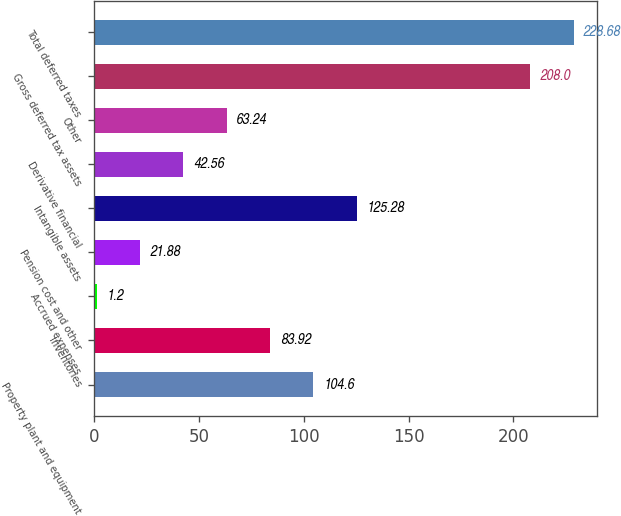<chart> <loc_0><loc_0><loc_500><loc_500><bar_chart><fcel>Property plant and equipment<fcel>Inventories<fcel>Accrued expenses<fcel>Pension cost and other<fcel>Intangible assets<fcel>Derivative financial<fcel>Other<fcel>Gross deferred tax assets<fcel>Total deferred taxes<nl><fcel>104.6<fcel>83.92<fcel>1.2<fcel>21.88<fcel>125.28<fcel>42.56<fcel>63.24<fcel>208<fcel>228.68<nl></chart> 